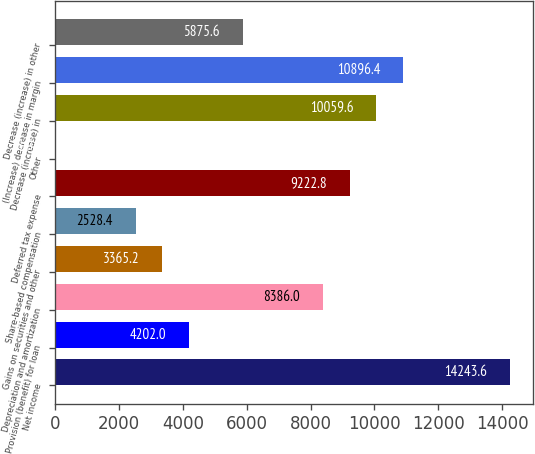<chart> <loc_0><loc_0><loc_500><loc_500><bar_chart><fcel>Net income<fcel>Provision (benefit) for loan<fcel>Depreciation and amortization<fcel>Gains on securities and other<fcel>Share-based compensation<fcel>Deferred tax expense<fcel>Other<fcel>Decrease (increase) in<fcel>(Increase) decrease in margin<fcel>Decrease (increase) in other<nl><fcel>14243.6<fcel>4202<fcel>8386<fcel>3365.2<fcel>2528.4<fcel>9222.8<fcel>18<fcel>10059.6<fcel>10896.4<fcel>5875.6<nl></chart> 